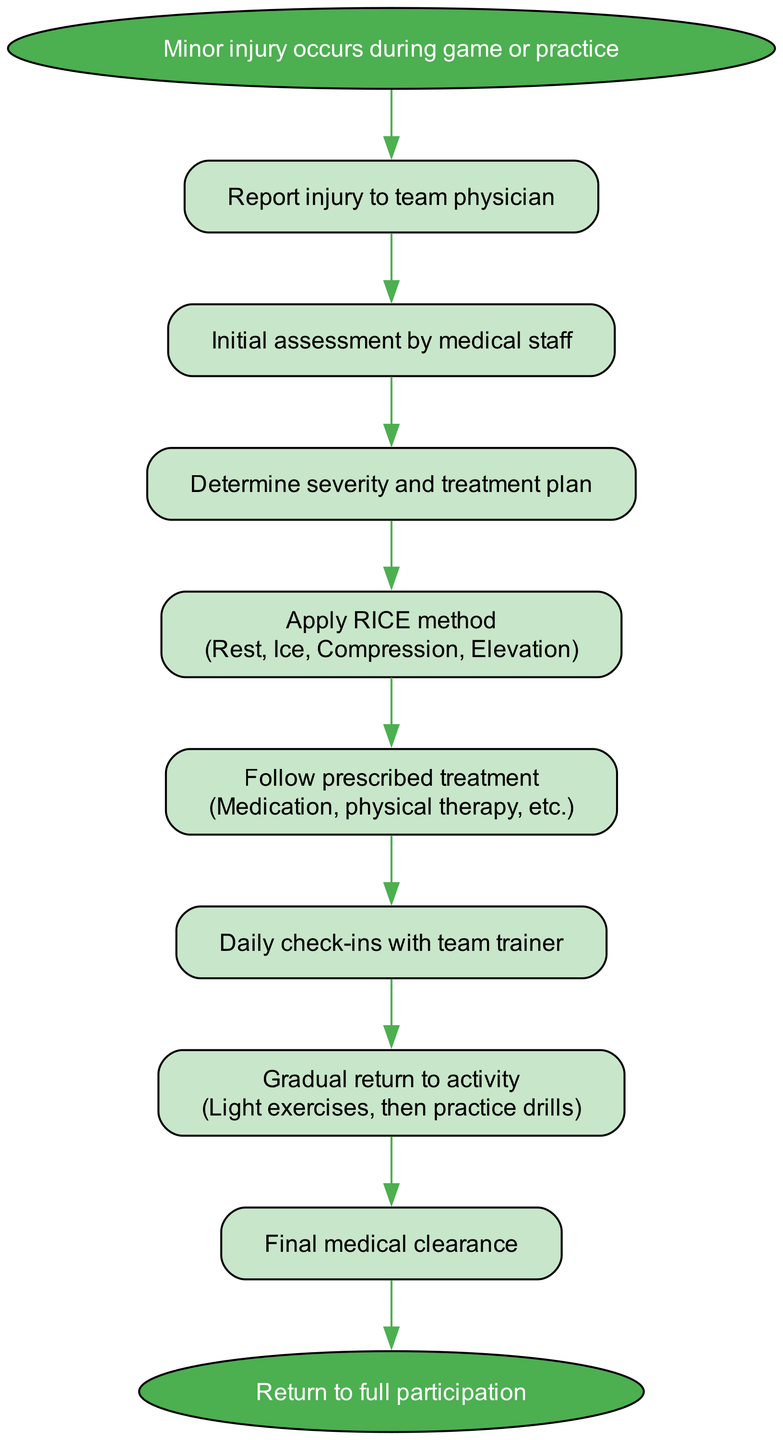What is the first action to take after a minor injury occurs? The diagram indicates that the first action is to "Report injury to team physician." This is the first step outlined in the procedure after the occurrence of a minor injury during a game or practice.
Answer: Report injury to team physician How many steps are there in the recovery procedure? By counting the steps listed in the diagram, it can be determined that there are 8 distinct steps from reporting the injury to returning to full participation.
Answer: 8 What is the final action before returning to full participation? The last action specified in the flow chart is "Final medical clearance." This step occurs immediately before the successful return to full participation in the team.
Answer: Final medical clearance Which method is applied after determining severity and treatment plan? According to the flow chart, following the step of determining the severity and treatment plan, the next action is to "Apply RICE method," which stands for Rest, Ice, Compression, and Elevation.
Answer: Apply RICE method What happens after daily check-ins with the team trainer? After the step for daily check-ins with the team trainer, the flow goes to "Gradual return to activity," indicating that the athlete would start to engage in light exercises and then practice drills.
Answer: Gradual return to activity Which step includes medication and physical therapy? The step that involves medication and physical therapy is "Follow prescribed treatment." This step comes after applying the RICE method and is crucial for recovery.
Answer: Follow prescribed treatment What is the purpose of the "Initial assessment by medical staff"? The purpose of this step is to "Determine severity and treatment plan." The initial assessment is necessary to evaluate the injury and decide on the appropriate course of action to promote healing.
Answer: Determine severity and treatment plan What is the relationship between “Apply RICE method” and “Follow prescribed treatment”? The diagram shows that after "Apply RICE method," the next step is "Follow prescribed treatment," indicating a sequential relationship where the application of the RICE method precedes the following treatment protocols.
Answer: Sequential relationship 